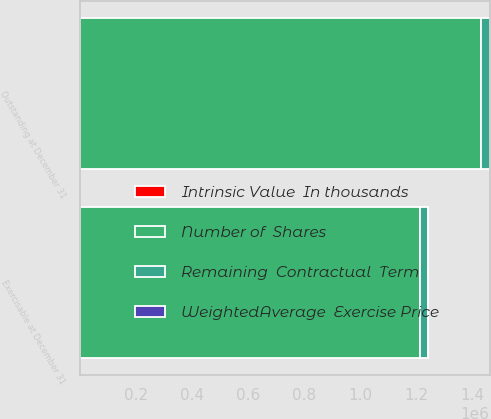<chart> <loc_0><loc_0><loc_500><loc_500><stacked_bar_chart><ecel><fcel>Outstanding at December 31<fcel>Exercisable at December 31<nl><fcel>Number of  Shares<fcel>1.42982e+06<fcel>1.2141e+06<nl><fcel>WeightedAverage  Exercise Price<fcel>13.62<fcel>12.1<nl><fcel>Intrinsic Value  In thousands<fcel>4.5<fcel>4<nl><fcel>Remaining  Contractual  Term<fcel>31002<fcel>28172<nl></chart> 